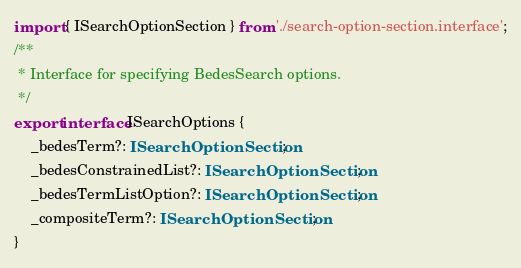<code> <loc_0><loc_0><loc_500><loc_500><_TypeScript_>import { ISearchOptionSection } from './search-option-section.interface';
/**
 * Interface for specifying BedesSearch options.
 */
export interface ISearchOptions {
    _bedesTerm?: ISearchOptionSection;
    _bedesConstrainedList?: ISearchOptionSection;
    _bedesTermListOption?: ISearchOptionSection;
    _compositeTerm?: ISearchOptionSection;
}
</code> 